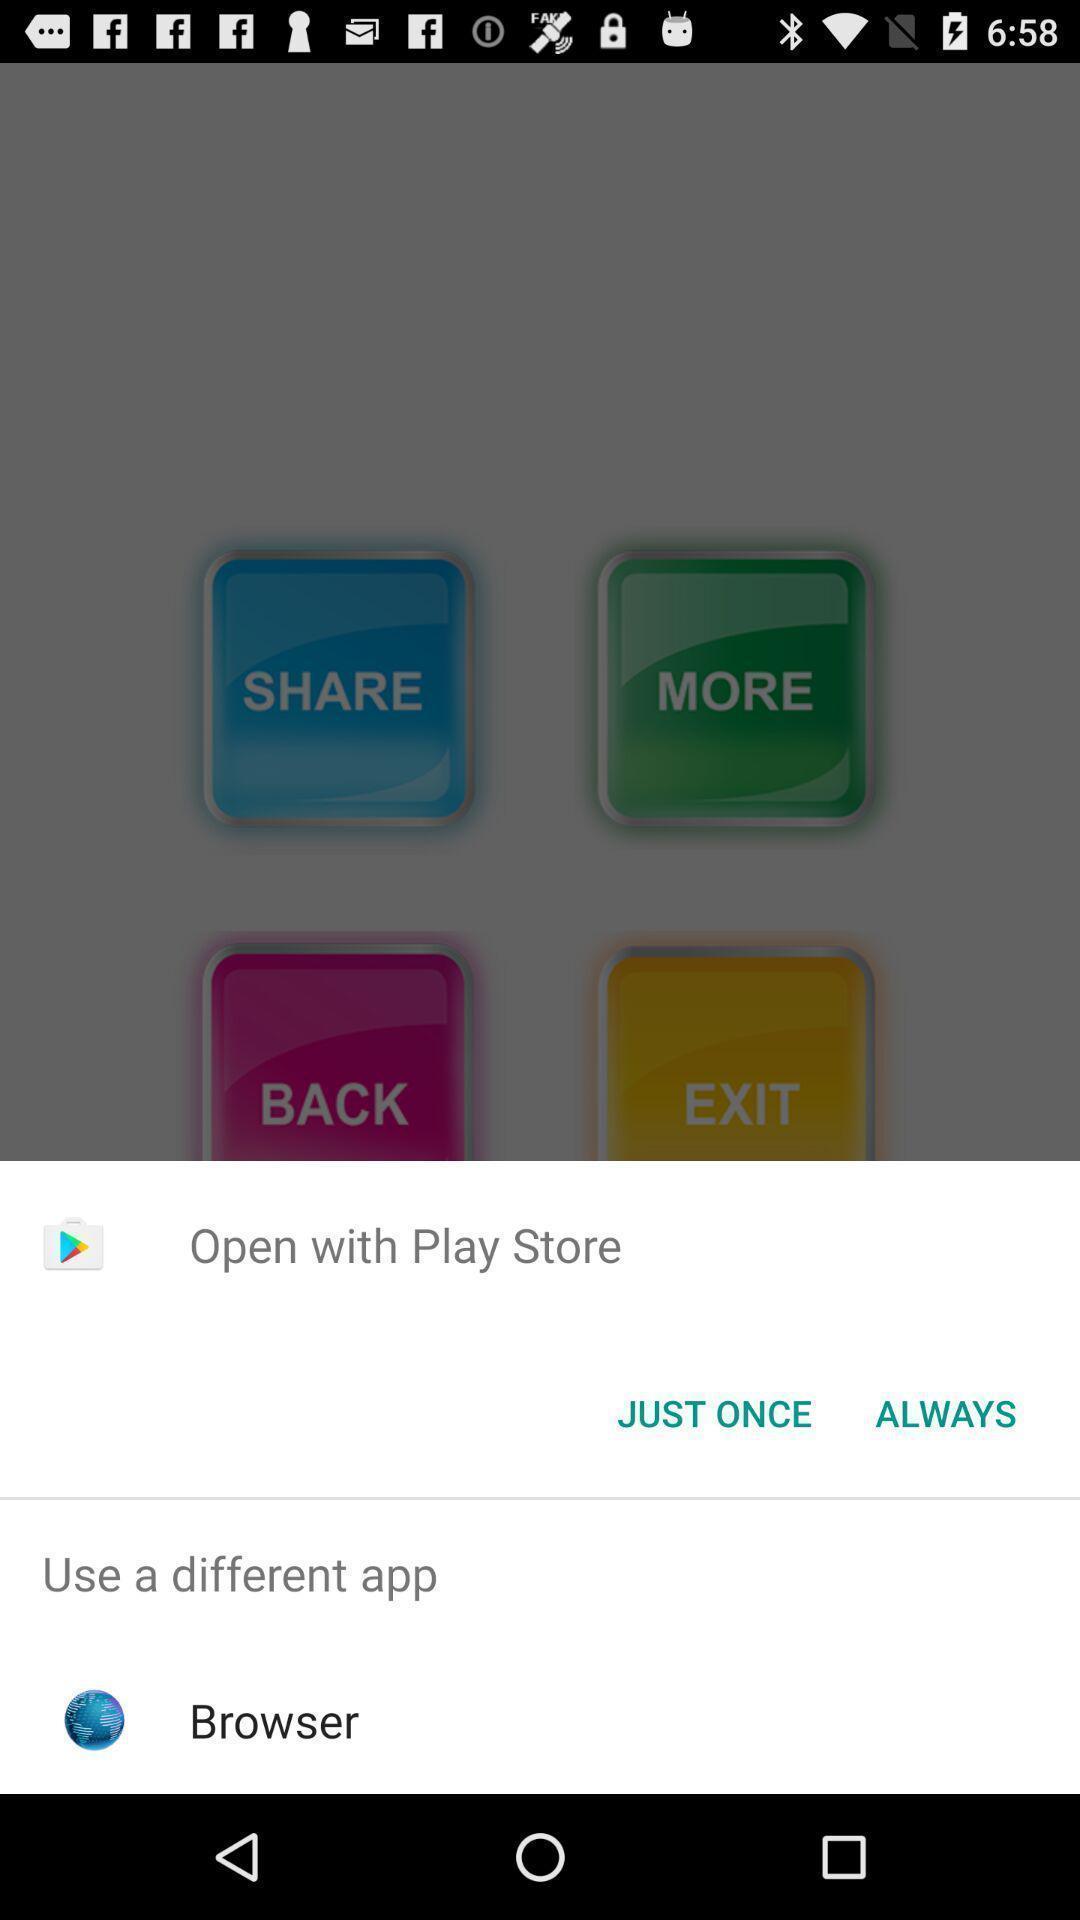Please provide a description for this image. Push up page showing app preference to open. 